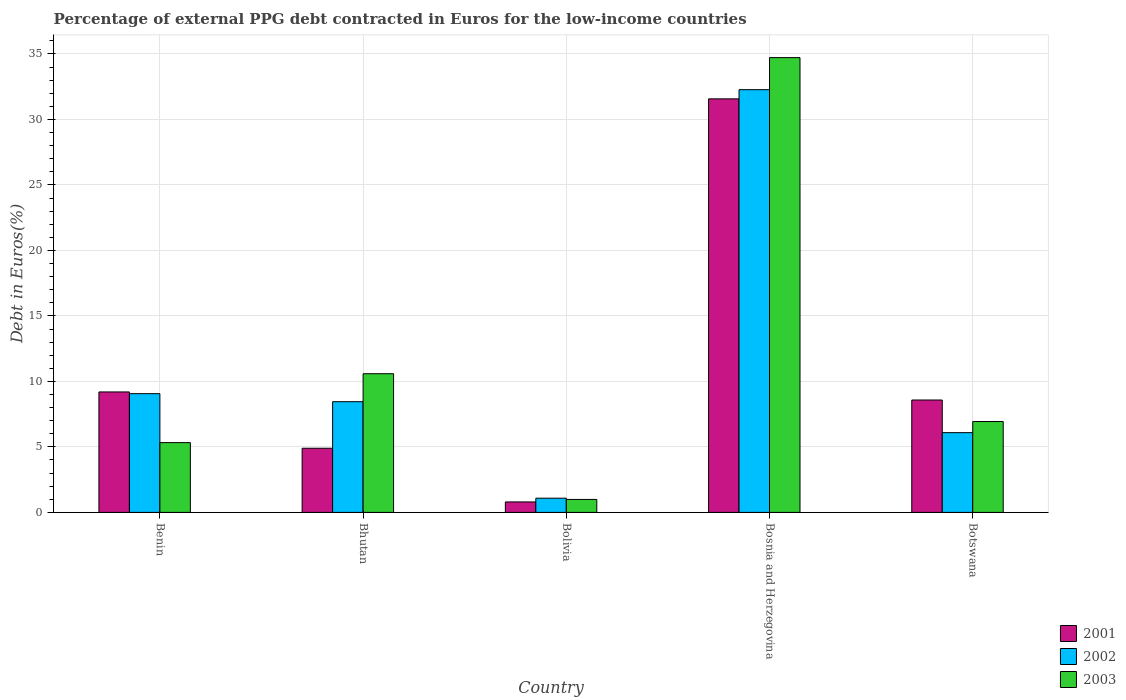How many groups of bars are there?
Your response must be concise. 5. Are the number of bars per tick equal to the number of legend labels?
Offer a very short reply. Yes. What is the label of the 5th group of bars from the left?
Your response must be concise. Botswana. In how many cases, is the number of bars for a given country not equal to the number of legend labels?
Provide a succinct answer. 0. What is the percentage of external PPG debt contracted in Euros in 2003 in Benin?
Provide a short and direct response. 5.33. Across all countries, what is the maximum percentage of external PPG debt contracted in Euros in 2002?
Ensure brevity in your answer.  32.27. In which country was the percentage of external PPG debt contracted in Euros in 2001 maximum?
Make the answer very short. Bosnia and Herzegovina. What is the total percentage of external PPG debt contracted in Euros in 2002 in the graph?
Your response must be concise. 56.95. What is the difference between the percentage of external PPG debt contracted in Euros in 2003 in Bosnia and Herzegovina and that in Botswana?
Give a very brief answer. 27.78. What is the difference between the percentage of external PPG debt contracted in Euros in 2003 in Bosnia and Herzegovina and the percentage of external PPG debt contracted in Euros in 2002 in Bhutan?
Ensure brevity in your answer.  26.27. What is the average percentage of external PPG debt contracted in Euros in 2002 per country?
Keep it short and to the point. 11.39. What is the difference between the percentage of external PPG debt contracted in Euros of/in 2002 and percentage of external PPG debt contracted in Euros of/in 2003 in Bolivia?
Make the answer very short. 0.09. In how many countries, is the percentage of external PPG debt contracted in Euros in 2003 greater than 1 %?
Offer a terse response. 4. What is the ratio of the percentage of external PPG debt contracted in Euros in 2002 in Benin to that in Bolivia?
Offer a very short reply. 8.36. Is the percentage of external PPG debt contracted in Euros in 2001 in Bolivia less than that in Bosnia and Herzegovina?
Make the answer very short. Yes. Is the difference between the percentage of external PPG debt contracted in Euros in 2002 in Bosnia and Herzegovina and Botswana greater than the difference between the percentage of external PPG debt contracted in Euros in 2003 in Bosnia and Herzegovina and Botswana?
Make the answer very short. No. What is the difference between the highest and the second highest percentage of external PPG debt contracted in Euros in 2002?
Give a very brief answer. 23.21. What is the difference between the highest and the lowest percentage of external PPG debt contracted in Euros in 2003?
Your response must be concise. 33.73. What does the 1st bar from the right in Bhutan represents?
Your answer should be very brief. 2003. Is it the case that in every country, the sum of the percentage of external PPG debt contracted in Euros in 2001 and percentage of external PPG debt contracted in Euros in 2003 is greater than the percentage of external PPG debt contracted in Euros in 2002?
Your answer should be very brief. Yes. Are all the bars in the graph horizontal?
Ensure brevity in your answer.  No. How many countries are there in the graph?
Offer a very short reply. 5. Does the graph contain grids?
Make the answer very short. Yes. Where does the legend appear in the graph?
Make the answer very short. Bottom right. How are the legend labels stacked?
Keep it short and to the point. Vertical. What is the title of the graph?
Offer a very short reply. Percentage of external PPG debt contracted in Euros for the low-income countries. Does "1961" appear as one of the legend labels in the graph?
Provide a short and direct response. No. What is the label or title of the X-axis?
Your answer should be compact. Country. What is the label or title of the Y-axis?
Provide a succinct answer. Debt in Euros(%). What is the Debt in Euros(%) of 2001 in Benin?
Make the answer very short. 9.19. What is the Debt in Euros(%) in 2002 in Benin?
Your answer should be very brief. 9.06. What is the Debt in Euros(%) in 2003 in Benin?
Make the answer very short. 5.33. What is the Debt in Euros(%) of 2001 in Bhutan?
Make the answer very short. 4.9. What is the Debt in Euros(%) in 2002 in Bhutan?
Make the answer very short. 8.45. What is the Debt in Euros(%) in 2003 in Bhutan?
Provide a short and direct response. 10.59. What is the Debt in Euros(%) of 2001 in Bolivia?
Give a very brief answer. 0.8. What is the Debt in Euros(%) in 2002 in Bolivia?
Offer a terse response. 1.08. What is the Debt in Euros(%) in 2001 in Bosnia and Herzegovina?
Give a very brief answer. 31.57. What is the Debt in Euros(%) in 2002 in Bosnia and Herzegovina?
Provide a succinct answer. 32.27. What is the Debt in Euros(%) in 2003 in Bosnia and Herzegovina?
Make the answer very short. 34.72. What is the Debt in Euros(%) of 2001 in Botswana?
Give a very brief answer. 8.58. What is the Debt in Euros(%) in 2002 in Botswana?
Make the answer very short. 6.09. What is the Debt in Euros(%) of 2003 in Botswana?
Make the answer very short. 6.94. Across all countries, what is the maximum Debt in Euros(%) of 2001?
Keep it short and to the point. 31.57. Across all countries, what is the maximum Debt in Euros(%) in 2002?
Provide a short and direct response. 32.27. Across all countries, what is the maximum Debt in Euros(%) in 2003?
Make the answer very short. 34.72. Across all countries, what is the minimum Debt in Euros(%) of 2001?
Provide a succinct answer. 0.8. Across all countries, what is the minimum Debt in Euros(%) of 2002?
Your response must be concise. 1.08. Across all countries, what is the minimum Debt in Euros(%) in 2003?
Provide a succinct answer. 0.99. What is the total Debt in Euros(%) of 2001 in the graph?
Offer a very short reply. 55.04. What is the total Debt in Euros(%) in 2002 in the graph?
Your answer should be compact. 56.95. What is the total Debt in Euros(%) in 2003 in the graph?
Your answer should be compact. 58.56. What is the difference between the Debt in Euros(%) of 2001 in Benin and that in Bhutan?
Your answer should be compact. 4.3. What is the difference between the Debt in Euros(%) in 2002 in Benin and that in Bhutan?
Your response must be concise. 0.61. What is the difference between the Debt in Euros(%) in 2003 in Benin and that in Bhutan?
Keep it short and to the point. -5.26. What is the difference between the Debt in Euros(%) of 2001 in Benin and that in Bolivia?
Offer a very short reply. 8.4. What is the difference between the Debt in Euros(%) of 2002 in Benin and that in Bolivia?
Your response must be concise. 7.98. What is the difference between the Debt in Euros(%) of 2003 in Benin and that in Bolivia?
Keep it short and to the point. 4.34. What is the difference between the Debt in Euros(%) in 2001 in Benin and that in Bosnia and Herzegovina?
Provide a short and direct response. -22.37. What is the difference between the Debt in Euros(%) of 2002 in Benin and that in Bosnia and Herzegovina?
Make the answer very short. -23.21. What is the difference between the Debt in Euros(%) in 2003 in Benin and that in Bosnia and Herzegovina?
Make the answer very short. -29.39. What is the difference between the Debt in Euros(%) of 2001 in Benin and that in Botswana?
Your response must be concise. 0.62. What is the difference between the Debt in Euros(%) of 2002 in Benin and that in Botswana?
Ensure brevity in your answer.  2.98. What is the difference between the Debt in Euros(%) in 2003 in Benin and that in Botswana?
Your answer should be very brief. -1.61. What is the difference between the Debt in Euros(%) in 2001 in Bhutan and that in Bolivia?
Offer a terse response. 4.1. What is the difference between the Debt in Euros(%) of 2002 in Bhutan and that in Bolivia?
Your answer should be compact. 7.37. What is the difference between the Debt in Euros(%) of 2003 in Bhutan and that in Bolivia?
Offer a terse response. 9.6. What is the difference between the Debt in Euros(%) in 2001 in Bhutan and that in Bosnia and Herzegovina?
Offer a terse response. -26.67. What is the difference between the Debt in Euros(%) of 2002 in Bhutan and that in Bosnia and Herzegovina?
Offer a terse response. -23.82. What is the difference between the Debt in Euros(%) of 2003 in Bhutan and that in Bosnia and Herzegovina?
Your answer should be compact. -24.13. What is the difference between the Debt in Euros(%) of 2001 in Bhutan and that in Botswana?
Make the answer very short. -3.68. What is the difference between the Debt in Euros(%) in 2002 in Bhutan and that in Botswana?
Offer a very short reply. 2.36. What is the difference between the Debt in Euros(%) of 2003 in Bhutan and that in Botswana?
Make the answer very short. 3.65. What is the difference between the Debt in Euros(%) in 2001 in Bolivia and that in Bosnia and Herzegovina?
Keep it short and to the point. -30.77. What is the difference between the Debt in Euros(%) of 2002 in Bolivia and that in Bosnia and Herzegovina?
Your answer should be very brief. -31.18. What is the difference between the Debt in Euros(%) of 2003 in Bolivia and that in Bosnia and Herzegovina?
Your answer should be very brief. -33.73. What is the difference between the Debt in Euros(%) in 2001 in Bolivia and that in Botswana?
Provide a succinct answer. -7.78. What is the difference between the Debt in Euros(%) of 2002 in Bolivia and that in Botswana?
Make the answer very short. -5. What is the difference between the Debt in Euros(%) in 2003 in Bolivia and that in Botswana?
Offer a terse response. -5.95. What is the difference between the Debt in Euros(%) of 2001 in Bosnia and Herzegovina and that in Botswana?
Offer a very short reply. 22.99. What is the difference between the Debt in Euros(%) in 2002 in Bosnia and Herzegovina and that in Botswana?
Your answer should be very brief. 26.18. What is the difference between the Debt in Euros(%) in 2003 in Bosnia and Herzegovina and that in Botswana?
Make the answer very short. 27.78. What is the difference between the Debt in Euros(%) of 2001 in Benin and the Debt in Euros(%) of 2002 in Bhutan?
Offer a terse response. 0.74. What is the difference between the Debt in Euros(%) in 2001 in Benin and the Debt in Euros(%) in 2003 in Bhutan?
Offer a very short reply. -1.39. What is the difference between the Debt in Euros(%) in 2002 in Benin and the Debt in Euros(%) in 2003 in Bhutan?
Offer a very short reply. -1.52. What is the difference between the Debt in Euros(%) in 2001 in Benin and the Debt in Euros(%) in 2002 in Bolivia?
Your answer should be compact. 8.11. What is the difference between the Debt in Euros(%) in 2001 in Benin and the Debt in Euros(%) in 2003 in Bolivia?
Keep it short and to the point. 8.21. What is the difference between the Debt in Euros(%) of 2002 in Benin and the Debt in Euros(%) of 2003 in Bolivia?
Provide a short and direct response. 8.07. What is the difference between the Debt in Euros(%) in 2001 in Benin and the Debt in Euros(%) in 2002 in Bosnia and Herzegovina?
Provide a succinct answer. -23.07. What is the difference between the Debt in Euros(%) of 2001 in Benin and the Debt in Euros(%) of 2003 in Bosnia and Herzegovina?
Your answer should be compact. -25.52. What is the difference between the Debt in Euros(%) of 2002 in Benin and the Debt in Euros(%) of 2003 in Bosnia and Herzegovina?
Keep it short and to the point. -25.65. What is the difference between the Debt in Euros(%) in 2001 in Benin and the Debt in Euros(%) in 2002 in Botswana?
Give a very brief answer. 3.11. What is the difference between the Debt in Euros(%) in 2001 in Benin and the Debt in Euros(%) in 2003 in Botswana?
Your answer should be compact. 2.26. What is the difference between the Debt in Euros(%) in 2002 in Benin and the Debt in Euros(%) in 2003 in Botswana?
Your response must be concise. 2.13. What is the difference between the Debt in Euros(%) in 2001 in Bhutan and the Debt in Euros(%) in 2002 in Bolivia?
Make the answer very short. 3.81. What is the difference between the Debt in Euros(%) in 2001 in Bhutan and the Debt in Euros(%) in 2003 in Bolivia?
Your response must be concise. 3.91. What is the difference between the Debt in Euros(%) of 2002 in Bhutan and the Debt in Euros(%) of 2003 in Bolivia?
Ensure brevity in your answer.  7.46. What is the difference between the Debt in Euros(%) in 2001 in Bhutan and the Debt in Euros(%) in 2002 in Bosnia and Herzegovina?
Provide a short and direct response. -27.37. What is the difference between the Debt in Euros(%) of 2001 in Bhutan and the Debt in Euros(%) of 2003 in Bosnia and Herzegovina?
Provide a short and direct response. -29.82. What is the difference between the Debt in Euros(%) of 2002 in Bhutan and the Debt in Euros(%) of 2003 in Bosnia and Herzegovina?
Provide a short and direct response. -26.27. What is the difference between the Debt in Euros(%) in 2001 in Bhutan and the Debt in Euros(%) in 2002 in Botswana?
Offer a very short reply. -1.19. What is the difference between the Debt in Euros(%) in 2001 in Bhutan and the Debt in Euros(%) in 2003 in Botswana?
Offer a terse response. -2.04. What is the difference between the Debt in Euros(%) of 2002 in Bhutan and the Debt in Euros(%) of 2003 in Botswana?
Ensure brevity in your answer.  1.51. What is the difference between the Debt in Euros(%) in 2001 in Bolivia and the Debt in Euros(%) in 2002 in Bosnia and Herzegovina?
Offer a very short reply. -31.47. What is the difference between the Debt in Euros(%) in 2001 in Bolivia and the Debt in Euros(%) in 2003 in Bosnia and Herzegovina?
Your answer should be compact. -33.92. What is the difference between the Debt in Euros(%) of 2002 in Bolivia and the Debt in Euros(%) of 2003 in Bosnia and Herzegovina?
Keep it short and to the point. -33.63. What is the difference between the Debt in Euros(%) in 2001 in Bolivia and the Debt in Euros(%) in 2002 in Botswana?
Your answer should be compact. -5.29. What is the difference between the Debt in Euros(%) in 2001 in Bolivia and the Debt in Euros(%) in 2003 in Botswana?
Make the answer very short. -6.14. What is the difference between the Debt in Euros(%) in 2002 in Bolivia and the Debt in Euros(%) in 2003 in Botswana?
Offer a very short reply. -5.85. What is the difference between the Debt in Euros(%) in 2001 in Bosnia and Herzegovina and the Debt in Euros(%) in 2002 in Botswana?
Make the answer very short. 25.48. What is the difference between the Debt in Euros(%) in 2001 in Bosnia and Herzegovina and the Debt in Euros(%) in 2003 in Botswana?
Provide a succinct answer. 24.63. What is the difference between the Debt in Euros(%) of 2002 in Bosnia and Herzegovina and the Debt in Euros(%) of 2003 in Botswana?
Provide a succinct answer. 25.33. What is the average Debt in Euros(%) in 2001 per country?
Provide a succinct answer. 11.01. What is the average Debt in Euros(%) in 2002 per country?
Make the answer very short. 11.39. What is the average Debt in Euros(%) in 2003 per country?
Provide a succinct answer. 11.71. What is the difference between the Debt in Euros(%) of 2001 and Debt in Euros(%) of 2002 in Benin?
Keep it short and to the point. 0.13. What is the difference between the Debt in Euros(%) of 2001 and Debt in Euros(%) of 2003 in Benin?
Offer a terse response. 3.87. What is the difference between the Debt in Euros(%) in 2002 and Debt in Euros(%) in 2003 in Benin?
Offer a very short reply. 3.74. What is the difference between the Debt in Euros(%) in 2001 and Debt in Euros(%) in 2002 in Bhutan?
Your answer should be very brief. -3.55. What is the difference between the Debt in Euros(%) in 2001 and Debt in Euros(%) in 2003 in Bhutan?
Give a very brief answer. -5.69. What is the difference between the Debt in Euros(%) of 2002 and Debt in Euros(%) of 2003 in Bhutan?
Your answer should be very brief. -2.14. What is the difference between the Debt in Euros(%) of 2001 and Debt in Euros(%) of 2002 in Bolivia?
Provide a succinct answer. -0.29. What is the difference between the Debt in Euros(%) of 2001 and Debt in Euros(%) of 2003 in Bolivia?
Offer a terse response. -0.19. What is the difference between the Debt in Euros(%) in 2002 and Debt in Euros(%) in 2003 in Bolivia?
Your answer should be very brief. 0.09. What is the difference between the Debt in Euros(%) in 2001 and Debt in Euros(%) in 2002 in Bosnia and Herzegovina?
Keep it short and to the point. -0.7. What is the difference between the Debt in Euros(%) in 2001 and Debt in Euros(%) in 2003 in Bosnia and Herzegovina?
Keep it short and to the point. -3.15. What is the difference between the Debt in Euros(%) in 2002 and Debt in Euros(%) in 2003 in Bosnia and Herzegovina?
Ensure brevity in your answer.  -2.45. What is the difference between the Debt in Euros(%) in 2001 and Debt in Euros(%) in 2002 in Botswana?
Ensure brevity in your answer.  2.49. What is the difference between the Debt in Euros(%) of 2001 and Debt in Euros(%) of 2003 in Botswana?
Make the answer very short. 1.64. What is the difference between the Debt in Euros(%) of 2002 and Debt in Euros(%) of 2003 in Botswana?
Give a very brief answer. -0.85. What is the ratio of the Debt in Euros(%) in 2001 in Benin to that in Bhutan?
Make the answer very short. 1.88. What is the ratio of the Debt in Euros(%) of 2002 in Benin to that in Bhutan?
Offer a terse response. 1.07. What is the ratio of the Debt in Euros(%) in 2003 in Benin to that in Bhutan?
Make the answer very short. 0.5. What is the ratio of the Debt in Euros(%) of 2001 in Benin to that in Bolivia?
Provide a succinct answer. 11.52. What is the ratio of the Debt in Euros(%) in 2002 in Benin to that in Bolivia?
Your answer should be very brief. 8.36. What is the ratio of the Debt in Euros(%) in 2003 in Benin to that in Bolivia?
Offer a very short reply. 5.38. What is the ratio of the Debt in Euros(%) of 2001 in Benin to that in Bosnia and Herzegovina?
Provide a short and direct response. 0.29. What is the ratio of the Debt in Euros(%) of 2002 in Benin to that in Bosnia and Herzegovina?
Offer a very short reply. 0.28. What is the ratio of the Debt in Euros(%) in 2003 in Benin to that in Bosnia and Herzegovina?
Your answer should be compact. 0.15. What is the ratio of the Debt in Euros(%) of 2001 in Benin to that in Botswana?
Your response must be concise. 1.07. What is the ratio of the Debt in Euros(%) in 2002 in Benin to that in Botswana?
Offer a terse response. 1.49. What is the ratio of the Debt in Euros(%) of 2003 in Benin to that in Botswana?
Give a very brief answer. 0.77. What is the ratio of the Debt in Euros(%) of 2001 in Bhutan to that in Bolivia?
Give a very brief answer. 6.13. What is the ratio of the Debt in Euros(%) of 2002 in Bhutan to that in Bolivia?
Your answer should be compact. 7.79. What is the ratio of the Debt in Euros(%) of 2003 in Bhutan to that in Bolivia?
Your answer should be compact. 10.7. What is the ratio of the Debt in Euros(%) in 2001 in Bhutan to that in Bosnia and Herzegovina?
Offer a terse response. 0.16. What is the ratio of the Debt in Euros(%) of 2002 in Bhutan to that in Bosnia and Herzegovina?
Ensure brevity in your answer.  0.26. What is the ratio of the Debt in Euros(%) of 2003 in Bhutan to that in Bosnia and Herzegovina?
Your response must be concise. 0.3. What is the ratio of the Debt in Euros(%) in 2001 in Bhutan to that in Botswana?
Provide a short and direct response. 0.57. What is the ratio of the Debt in Euros(%) in 2002 in Bhutan to that in Botswana?
Give a very brief answer. 1.39. What is the ratio of the Debt in Euros(%) of 2003 in Bhutan to that in Botswana?
Make the answer very short. 1.53. What is the ratio of the Debt in Euros(%) in 2001 in Bolivia to that in Bosnia and Herzegovina?
Make the answer very short. 0.03. What is the ratio of the Debt in Euros(%) in 2002 in Bolivia to that in Bosnia and Herzegovina?
Your response must be concise. 0.03. What is the ratio of the Debt in Euros(%) of 2003 in Bolivia to that in Bosnia and Herzegovina?
Keep it short and to the point. 0.03. What is the ratio of the Debt in Euros(%) in 2001 in Bolivia to that in Botswana?
Your answer should be very brief. 0.09. What is the ratio of the Debt in Euros(%) of 2002 in Bolivia to that in Botswana?
Keep it short and to the point. 0.18. What is the ratio of the Debt in Euros(%) of 2003 in Bolivia to that in Botswana?
Ensure brevity in your answer.  0.14. What is the ratio of the Debt in Euros(%) of 2001 in Bosnia and Herzegovina to that in Botswana?
Offer a very short reply. 3.68. What is the ratio of the Debt in Euros(%) in 2002 in Bosnia and Herzegovina to that in Botswana?
Provide a short and direct response. 5.3. What is the ratio of the Debt in Euros(%) of 2003 in Bosnia and Herzegovina to that in Botswana?
Ensure brevity in your answer.  5. What is the difference between the highest and the second highest Debt in Euros(%) in 2001?
Make the answer very short. 22.37. What is the difference between the highest and the second highest Debt in Euros(%) in 2002?
Offer a very short reply. 23.21. What is the difference between the highest and the second highest Debt in Euros(%) of 2003?
Offer a terse response. 24.13. What is the difference between the highest and the lowest Debt in Euros(%) in 2001?
Offer a very short reply. 30.77. What is the difference between the highest and the lowest Debt in Euros(%) of 2002?
Offer a very short reply. 31.18. What is the difference between the highest and the lowest Debt in Euros(%) of 2003?
Offer a terse response. 33.73. 